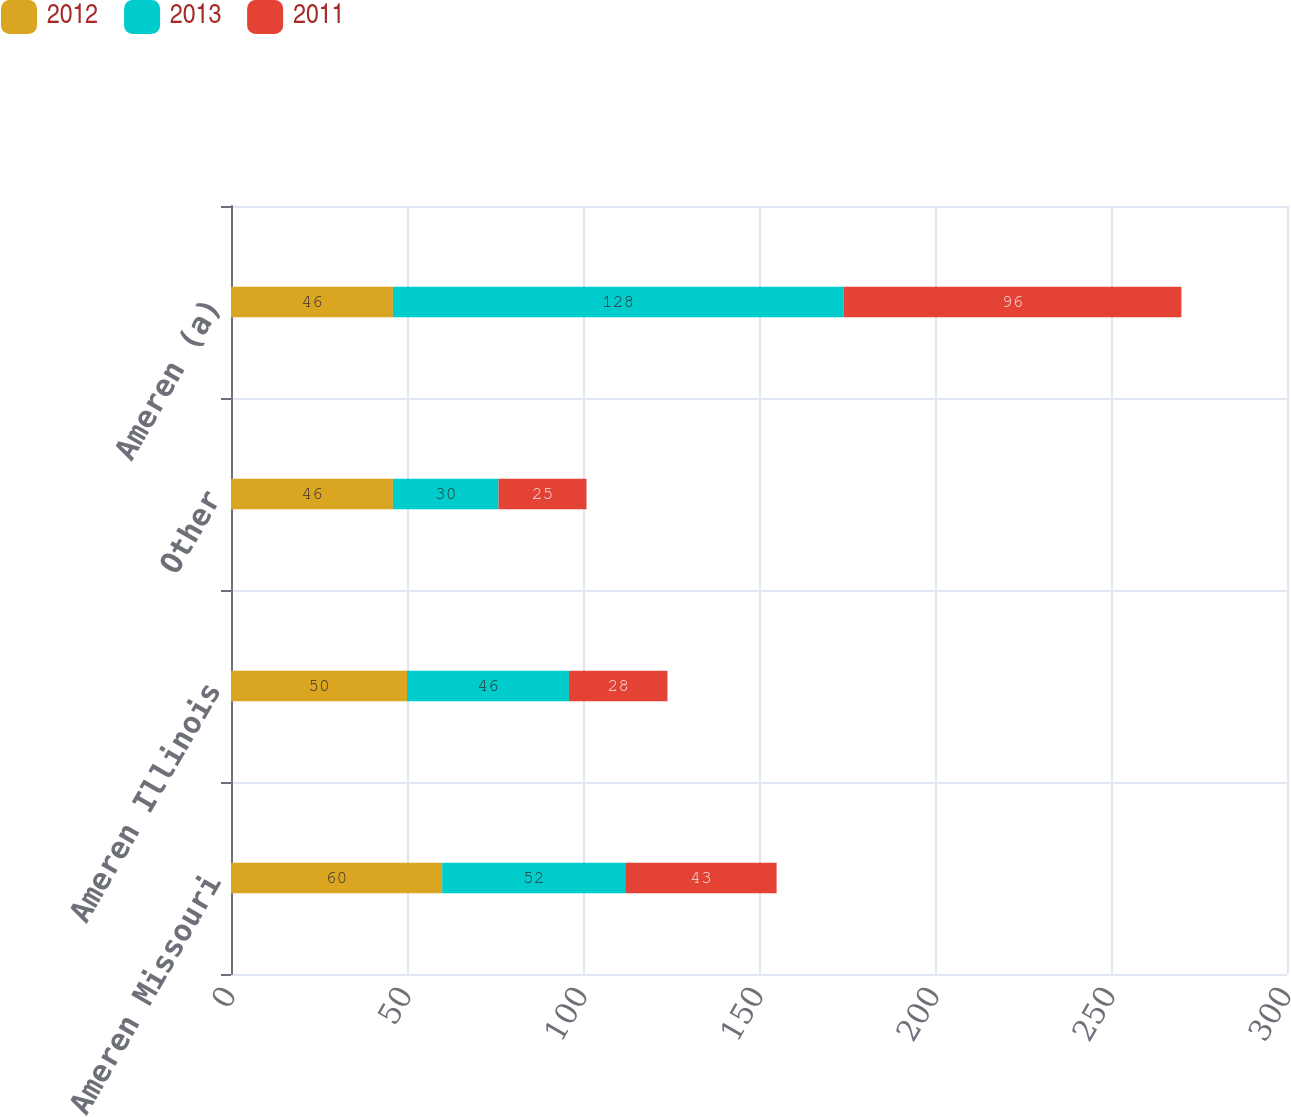Convert chart. <chart><loc_0><loc_0><loc_500><loc_500><stacked_bar_chart><ecel><fcel>Ameren Missouri<fcel>Ameren Illinois<fcel>Other<fcel>Ameren (a)<nl><fcel>2012<fcel>60<fcel>50<fcel>46<fcel>46<nl><fcel>2013<fcel>52<fcel>46<fcel>30<fcel>128<nl><fcel>2011<fcel>43<fcel>28<fcel>25<fcel>96<nl></chart> 